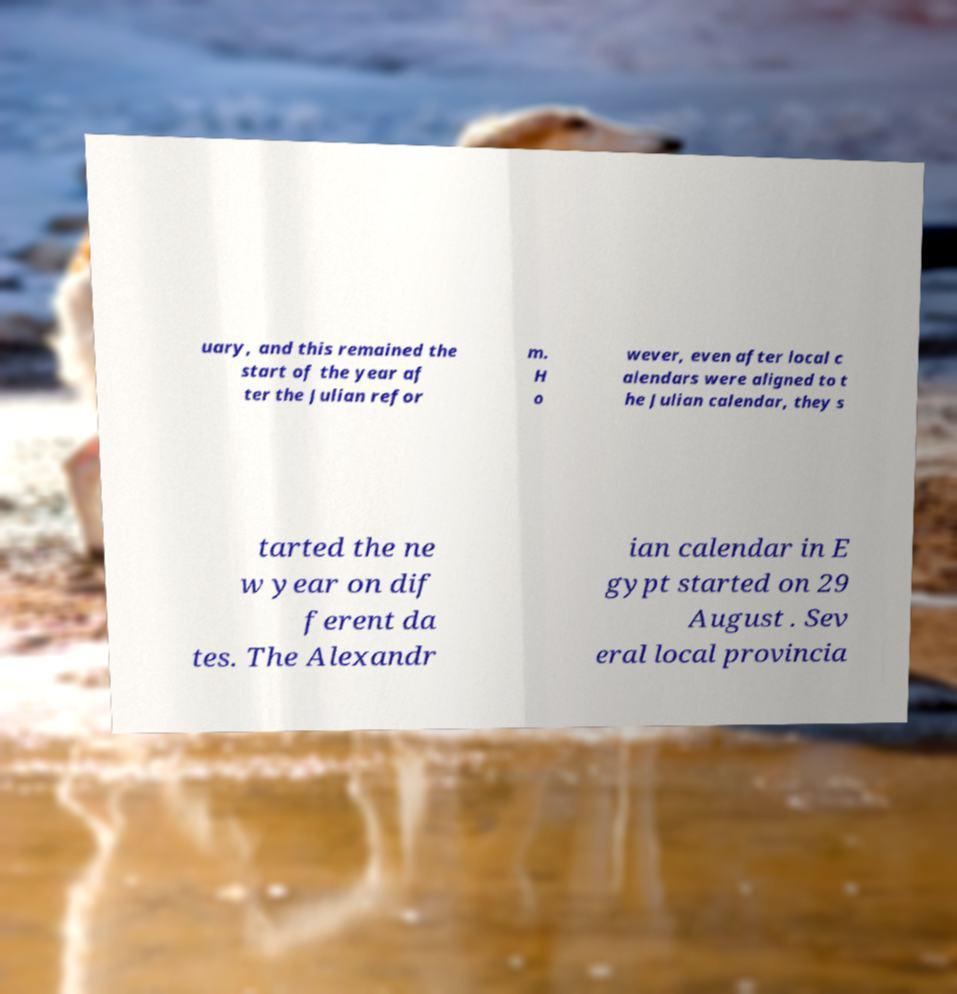Can you read and provide the text displayed in the image?This photo seems to have some interesting text. Can you extract and type it out for me? uary, and this remained the start of the year af ter the Julian refor m. H o wever, even after local c alendars were aligned to t he Julian calendar, they s tarted the ne w year on dif ferent da tes. The Alexandr ian calendar in E gypt started on 29 August . Sev eral local provincia 